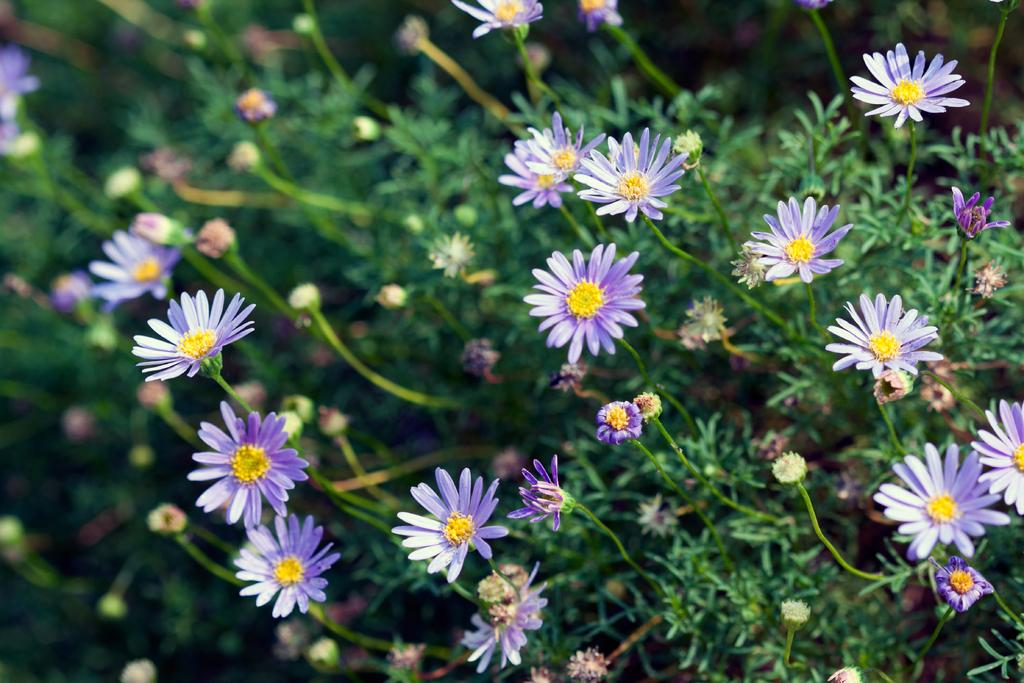What colors can be seen in the flowers of the plants in the image? There are violet and yellow color flowers in the plants. Are there any dinosaurs present in the image? No, there are no dinosaurs present in the image. 